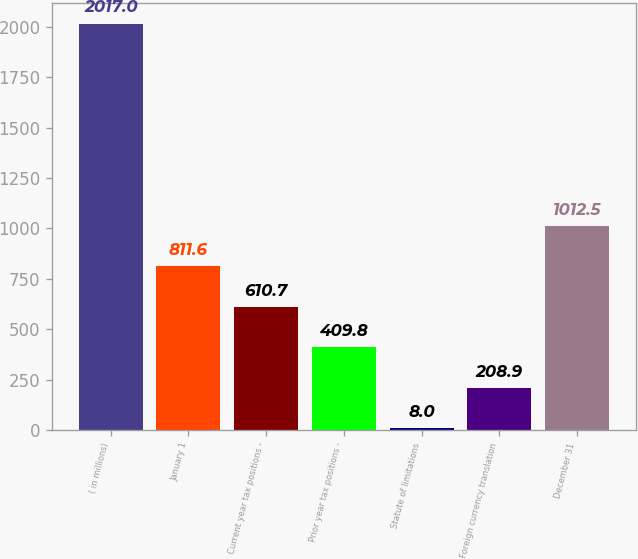Convert chart to OTSL. <chart><loc_0><loc_0><loc_500><loc_500><bar_chart><fcel>( in millions)<fcel>January 1<fcel>Current year tax positions -<fcel>Prior year tax positions -<fcel>Statute of limitations<fcel>Foreign currency translation<fcel>December 31<nl><fcel>2017<fcel>811.6<fcel>610.7<fcel>409.8<fcel>8<fcel>208.9<fcel>1012.5<nl></chart> 